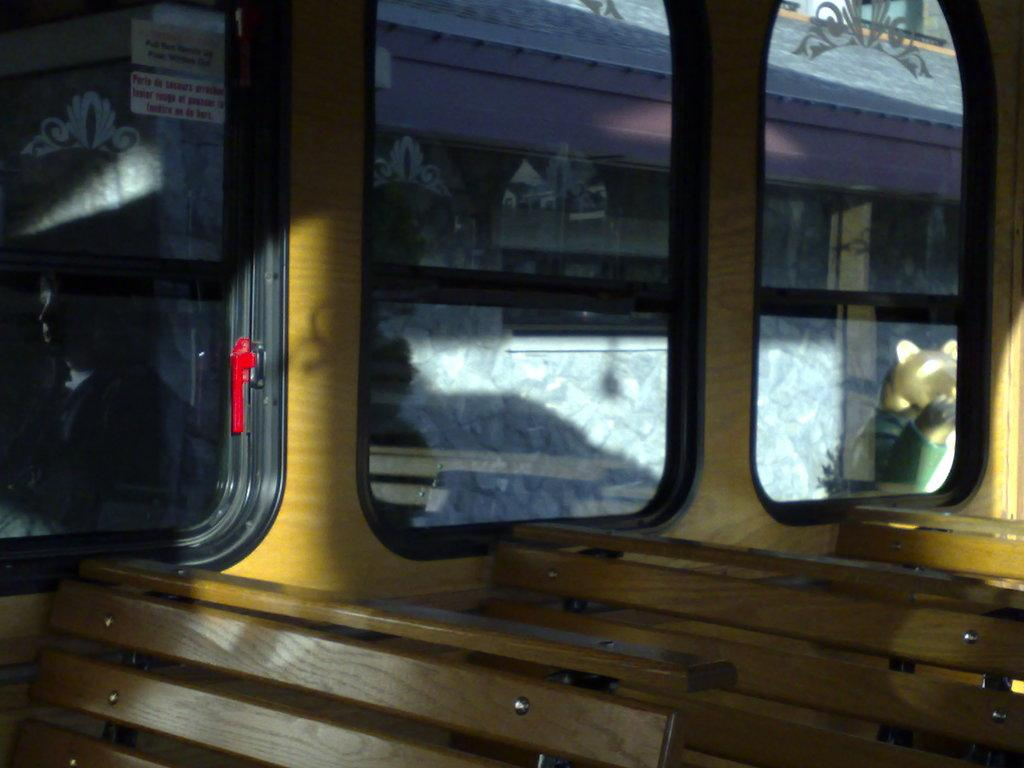What type of vehicle is shown in the image? The image shows an inside view of a bus. How many benches are present in the bus? There are three benches in the bus. What can be seen through the windows in the bus? A building is visible through the windows. Can you tell me how many people are jumping on the skateboard in the image? There is no skateboard or people jumping in the image; it shows an inside view of a bus. What type of channel is visible through the windows in the image? There is no channel visible through the windows in the image; only a building is visible. 